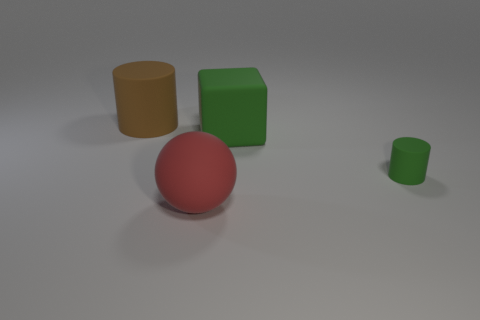There is a large ball that is made of the same material as the cube; what is its color?
Your answer should be compact. Red. Are there an equal number of spheres that are left of the brown thing and big green matte blocks?
Your answer should be very brief. No. Is the size of the cylinder that is to the left of the green cube the same as the big red object?
Make the answer very short. Yes. What is the color of the cylinder that is the same size as the cube?
Give a very brief answer. Brown. There is a cylinder on the right side of the matte thing behind the green matte block; is there a small green matte object that is left of it?
Ensure brevity in your answer.  No. What is the material of the cylinder that is to the right of the red object?
Offer a terse response. Rubber. Is the shape of the tiny green thing the same as the big thing that is on the left side of the red rubber sphere?
Give a very brief answer. Yes. Are there the same number of small rubber objects behind the brown object and large red rubber things that are behind the big red matte object?
Ensure brevity in your answer.  Yes. What number of other objects are there of the same material as the brown object?
Provide a succinct answer. 3. How many metal things are either tiny cylinders or red spheres?
Offer a terse response. 0. 